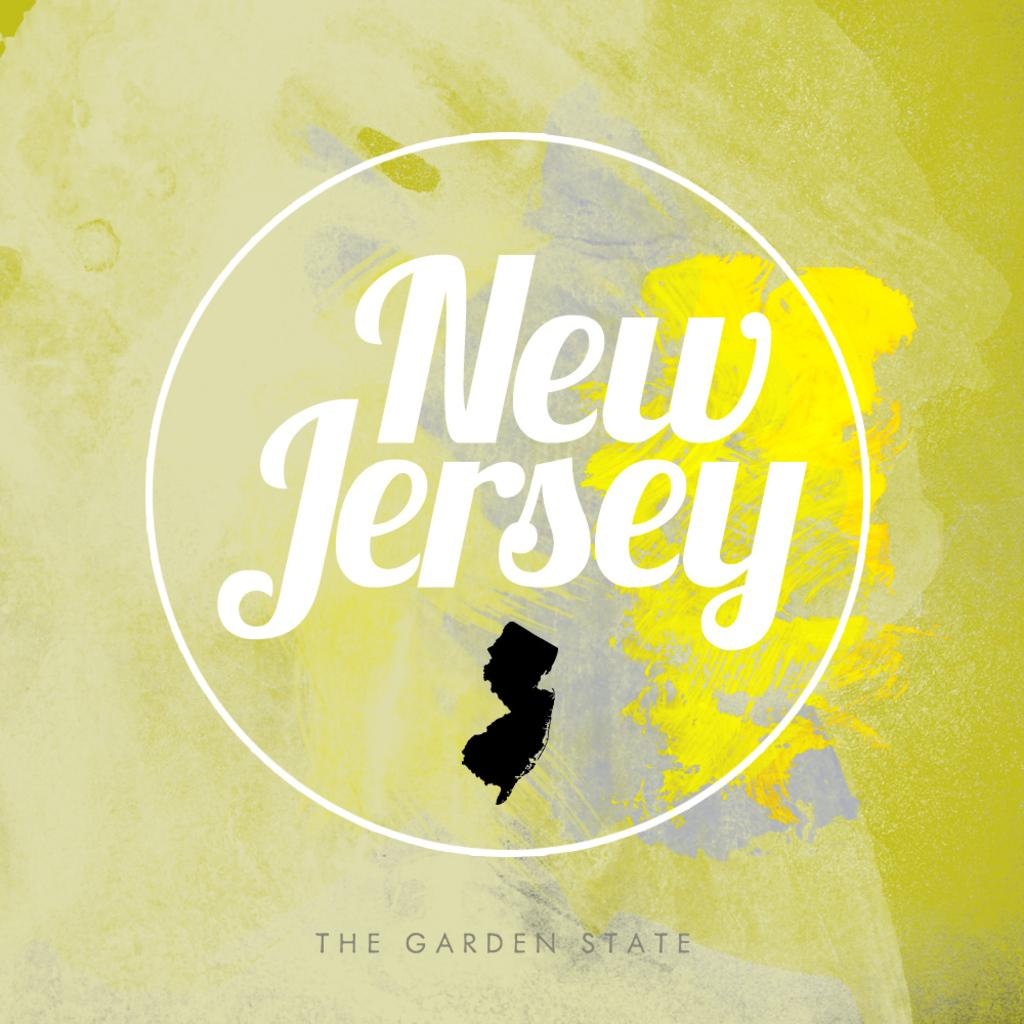<image>
Offer a succinct explanation of the picture presented. New Jersey the garden state poster filled with lots of different yellows 